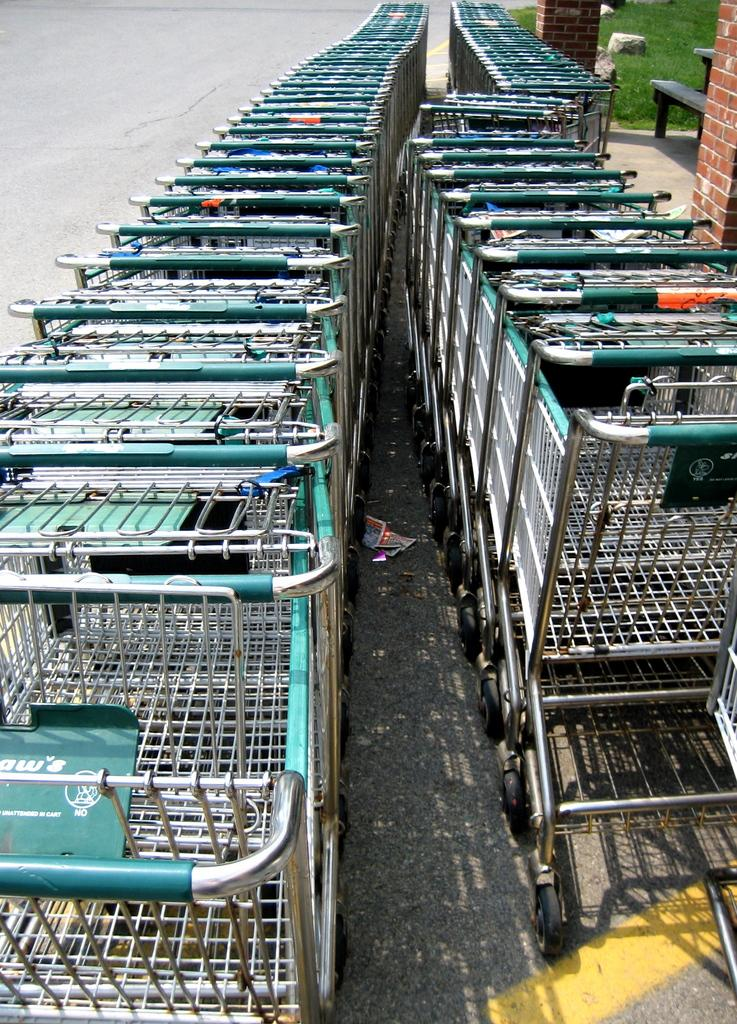<image>
Offer a succinct explanation of the picture presented. Shopping carts are lined uo and a sign on the cart says no in white letters. 